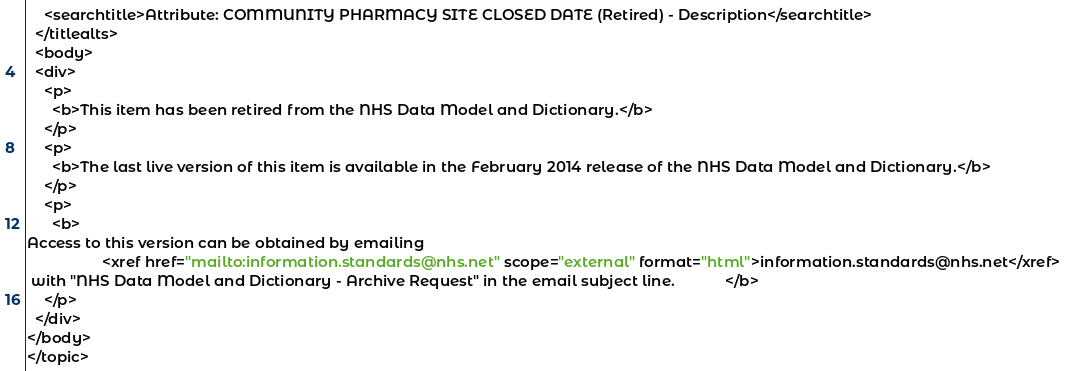Convert code to text. <code><loc_0><loc_0><loc_500><loc_500><_XML_>    <searchtitle>Attribute: COMMUNITY PHARMACY SITE CLOSED DATE (Retired) - Description</searchtitle>
  </titlealts>
  <body>
  <div>
    <p>
      <b>This item has been retired from the NHS Data Model and Dictionary.</b>
    </p>
    <p>
      <b>The last live version of this item is available in the February 2014 release of the NHS Data Model and Dictionary.</b>
    </p>
    <p>
      <b>
Access to this version can be obtained by emailing 
                  <xref href="mailto:information.standards@nhs.net" scope="external" format="html">information.standards@nhs.net</xref>
 with "NHS Data Model and Dictionary - Archive Request" in the email subject line.            </b>
    </p>
  </div>
</body>
</topic></code> 